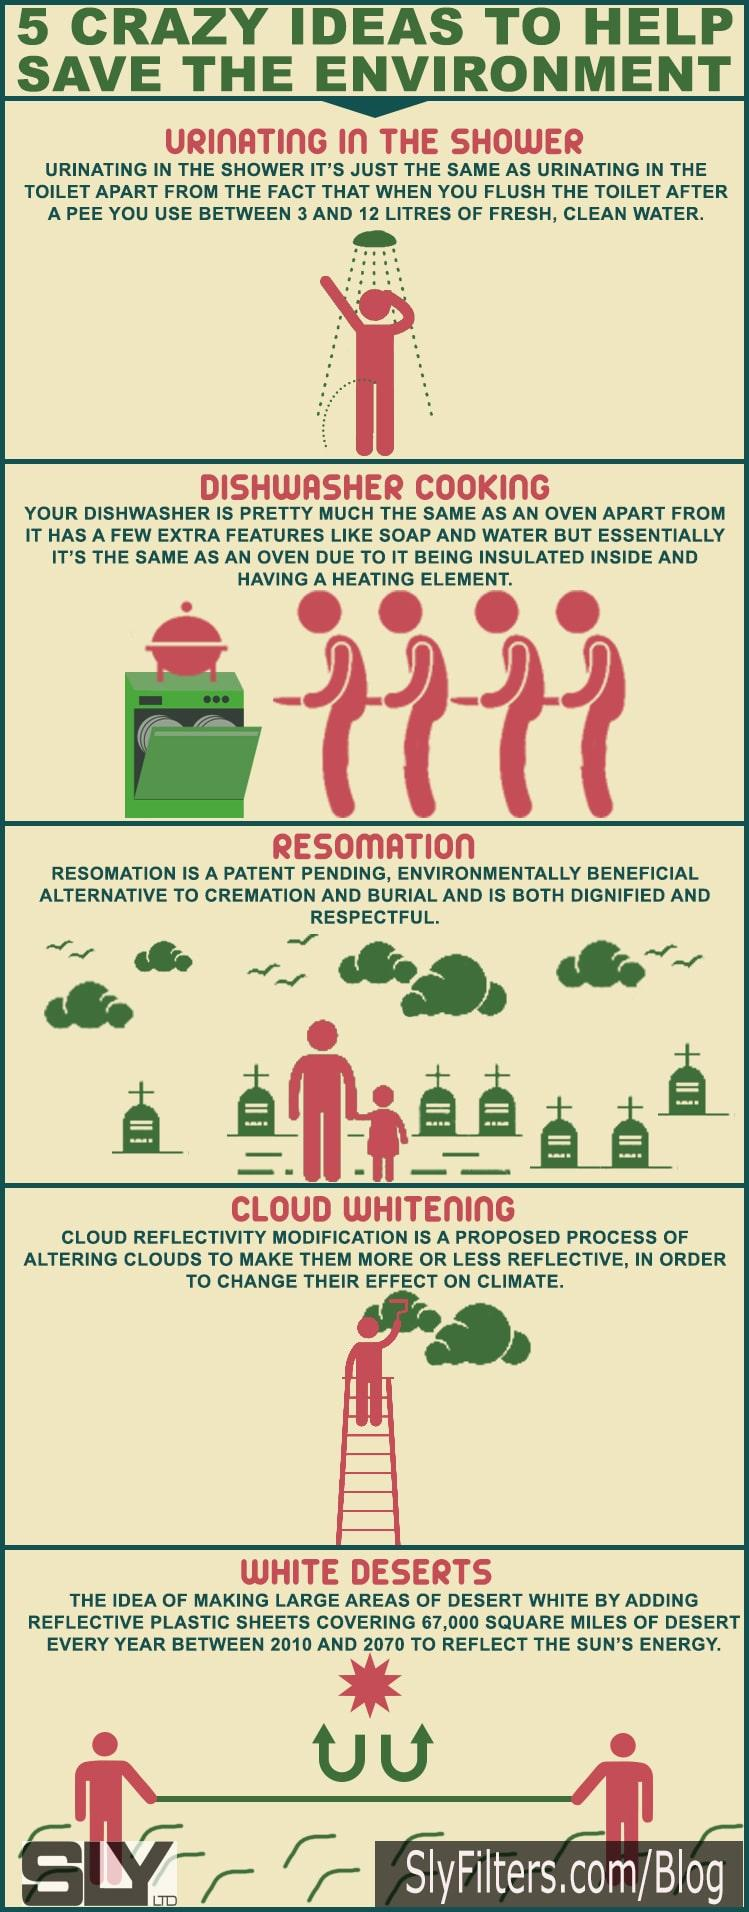Give some essential details in this illustration. It is the painter who is painting a cloud. The dishwasher lacks the ability to use soap and water, unlike the oven. The planned duration for White Deserts is a total of 60 years. There are a total of 7 gravestones that can be seen. The person in the image is urinating in the shower. 